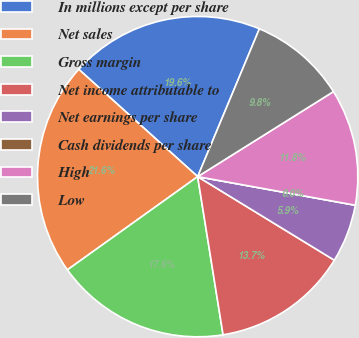Convert chart. <chart><loc_0><loc_0><loc_500><loc_500><pie_chart><fcel>In millions except per share<fcel>Net sales<fcel>Gross margin<fcel>Net income attributable to<fcel>Net earnings per share<fcel>Cash dividends per share<fcel>High<fcel>Low<nl><fcel>19.61%<fcel>21.57%<fcel>17.65%<fcel>13.73%<fcel>5.88%<fcel>0.0%<fcel>11.76%<fcel>9.8%<nl></chart> 